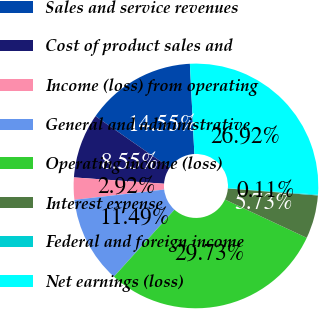Convert chart. <chart><loc_0><loc_0><loc_500><loc_500><pie_chart><fcel>Sales and service revenues<fcel>Cost of product sales and<fcel>Income (loss) from operating<fcel>General and administrative<fcel>Operating income (loss)<fcel>Interest expense<fcel>Federal and foreign income<fcel>Net earnings (loss)<nl><fcel>14.55%<fcel>8.55%<fcel>2.92%<fcel>11.49%<fcel>29.73%<fcel>5.73%<fcel>0.11%<fcel>26.92%<nl></chart> 